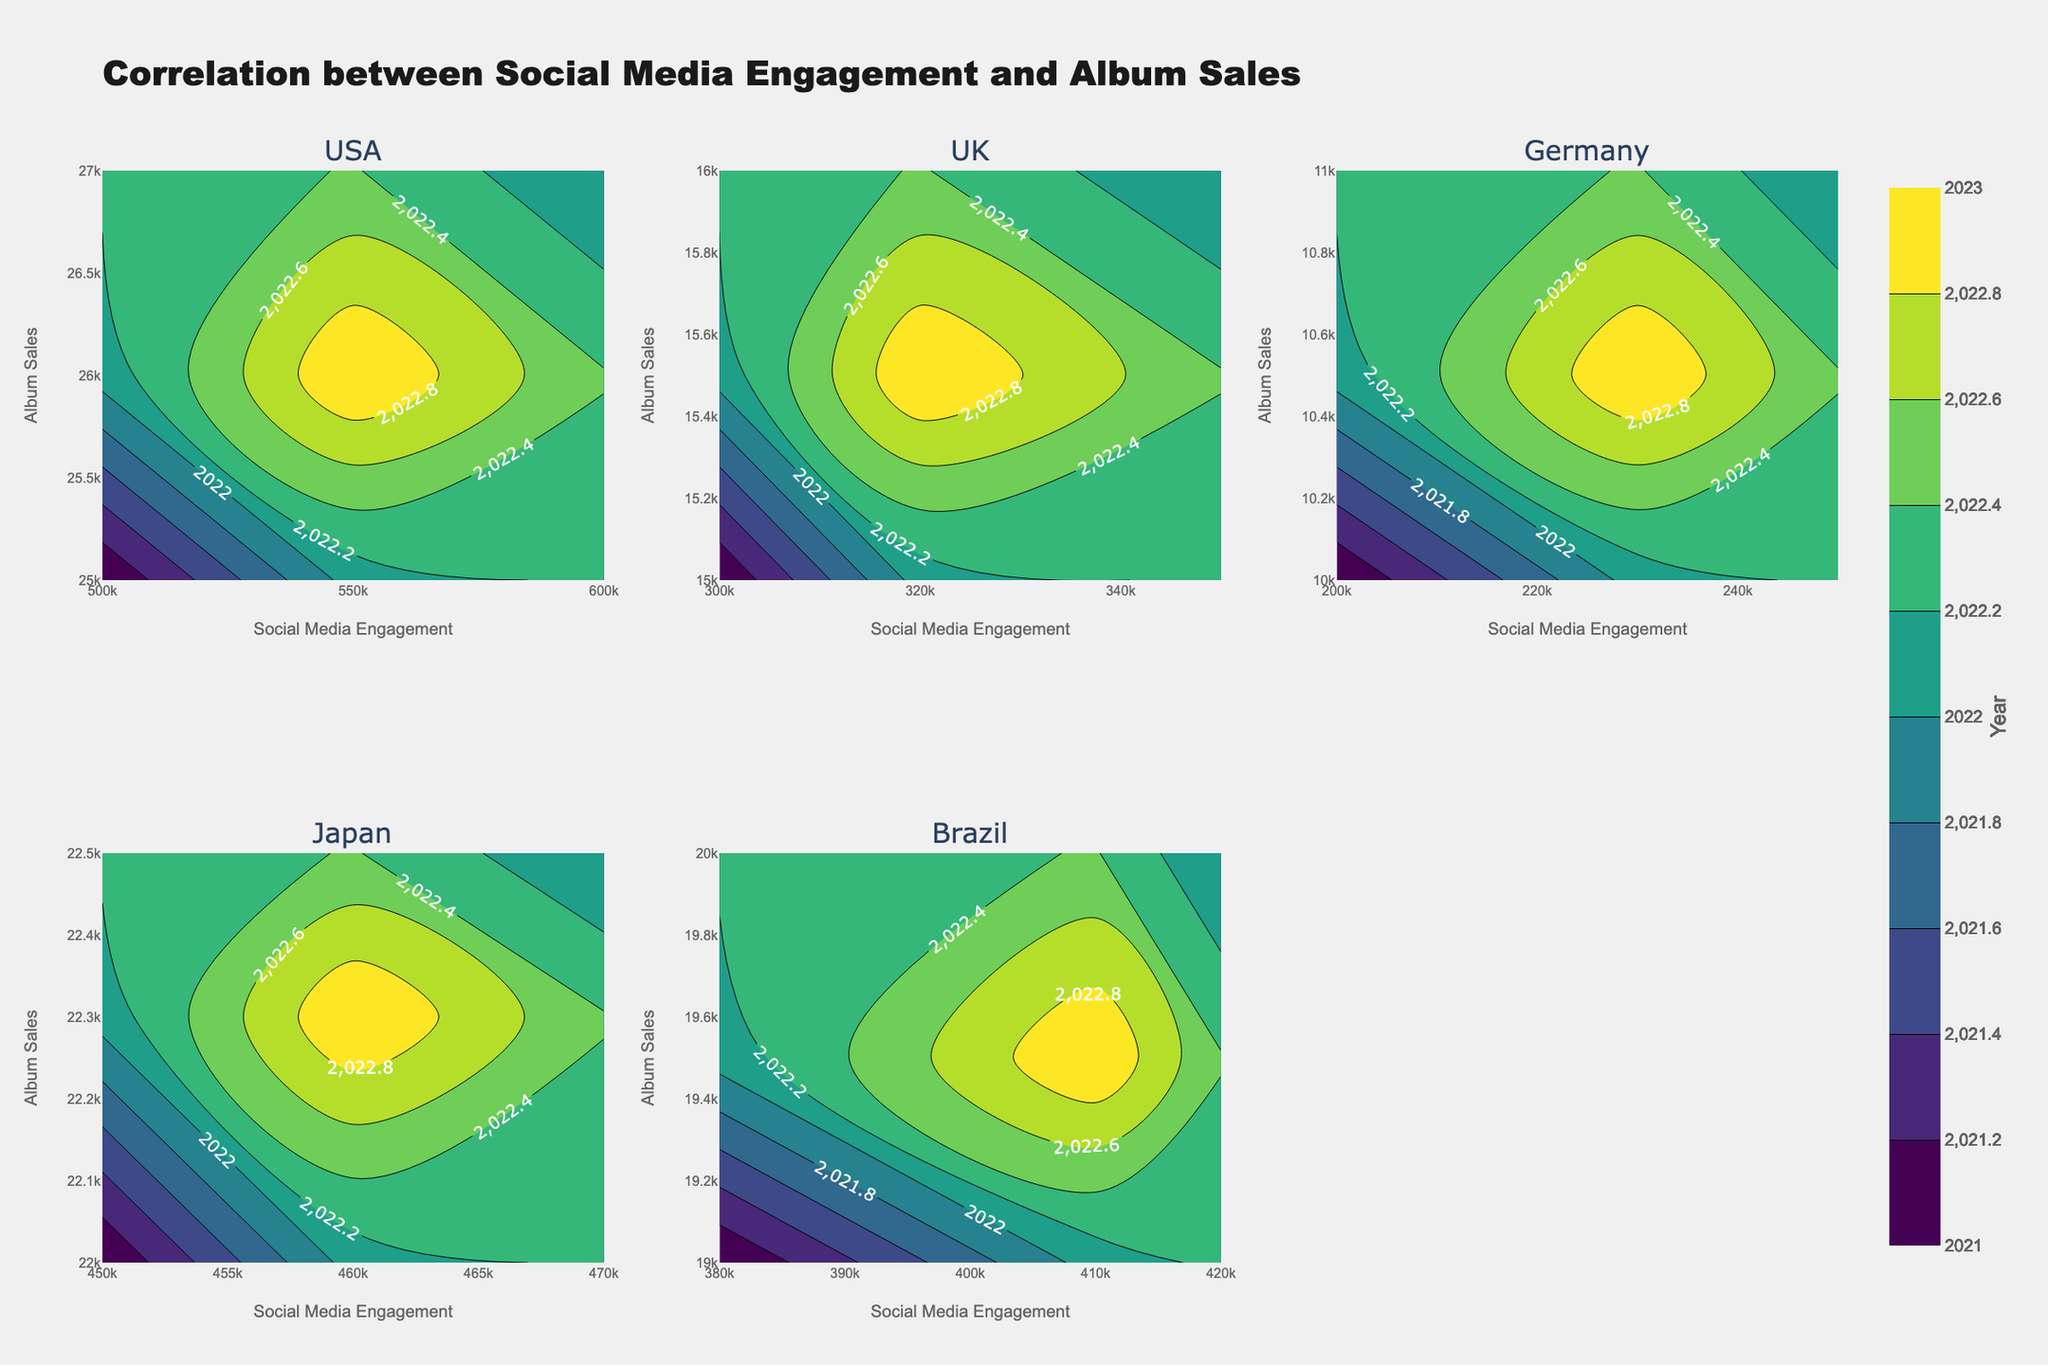What's the title of the figure? The title is usually found at the top of the figure and gives an overall idea of what the figure represents. In this case, it indicates the relationship being analyzed.
Answer: Correlation between Social Media Engagement and Album Sales Which countries are analyzed in the figure? The subplot titles will indicate the countries being analyzed, as each subplot title corresponds to a different country.
Answer: USA, UK, Germany, Japan, Brazil What are the x-axis and y-axis representing? The x-axis and y-axis labels on each subplot indicate the variables being compared. Here, the x-axis represents social media engagement levels, and the y-axis represents album sales.
Answer: Social Media Engagement Levels, Album Sales Which country shows the highest social media engagement level? To determine this, look at the x-axis range on each subplot and identify the highest value.
Answer: USA For which country do album sales peak at the highest social media engagement level? Compare the peaks of album sales in each country's subplot at the maximum x-axis value.
Answer: USA How does the color scale represent the data? The color scale, indicated by the color bar, represents years in this figure. Different colors correspond to different years.
Answer: Years (2021, 2022, 2023) Which country has the lowest number of album sales? By examining the y-axis of each subplot, identify the country with the lowest starting point on the y-axis.
Answer: Germany In which country do the social media engagement levels vary the least over the years? Look for the subplot where the contour lines are closest together along the x-axis, indicating smaller changes in social media engagement over the years.
Answer: Japan Are there any countries where album sales show a clear increase with higher social media engagement? Identify subplots where there is an apparent upward trend in album sales as social media engagement increases.
Answer: USA, Brazil 